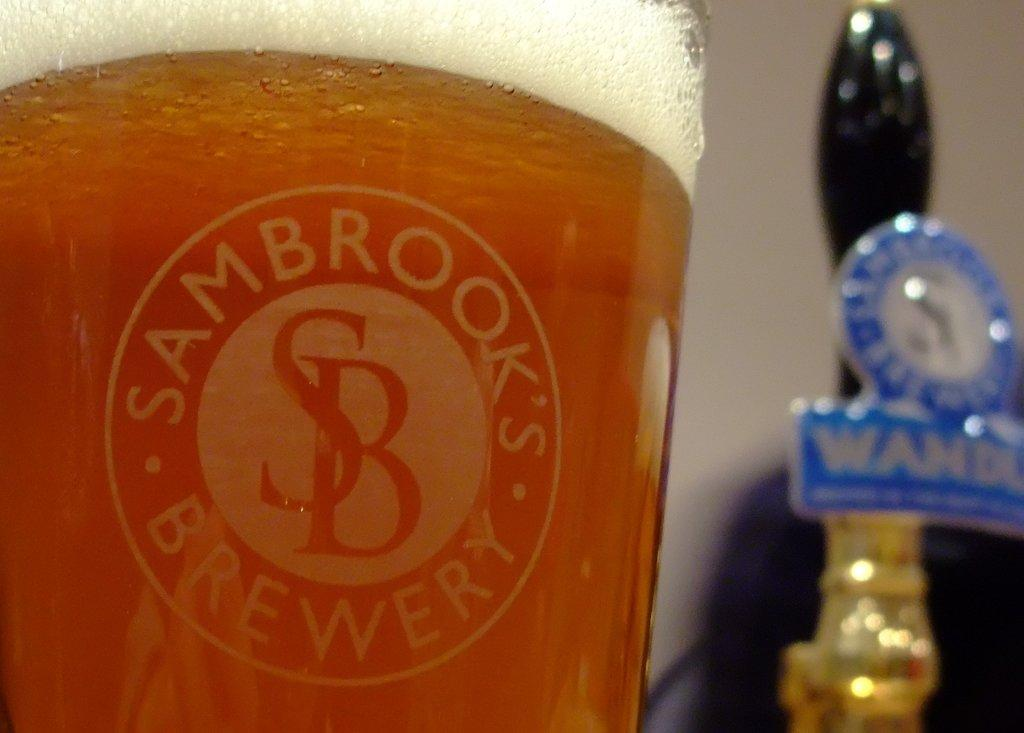<image>
Describe the image concisely. A glass full of liquid displays the name Sambrook's Brewery. 